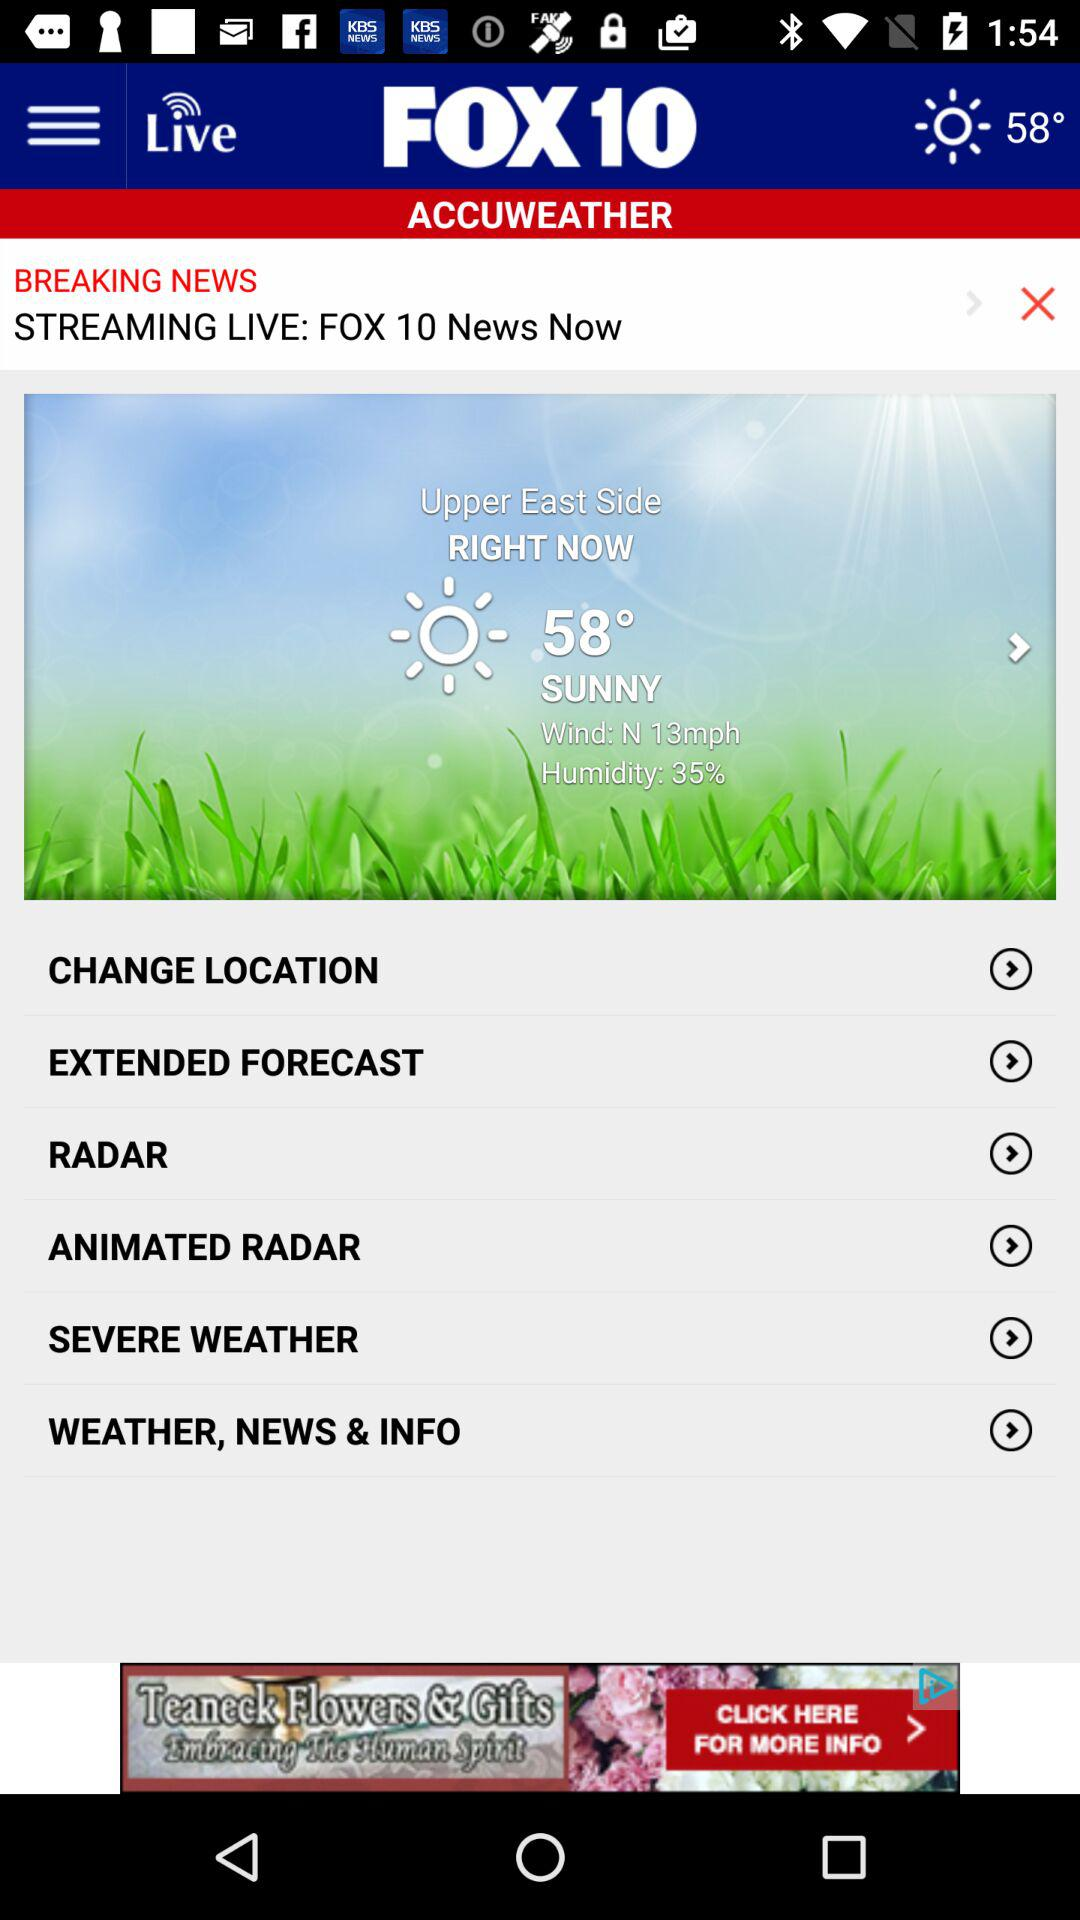What is length of wind? The length of the wind is "N". 